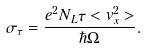<formula> <loc_0><loc_0><loc_500><loc_500>\sigma _ { \tau } = \frac { e ^ { 2 } N _ { L } \tau < v _ { x } ^ { 2 } > } { \hbar { \Omega } } .</formula> 